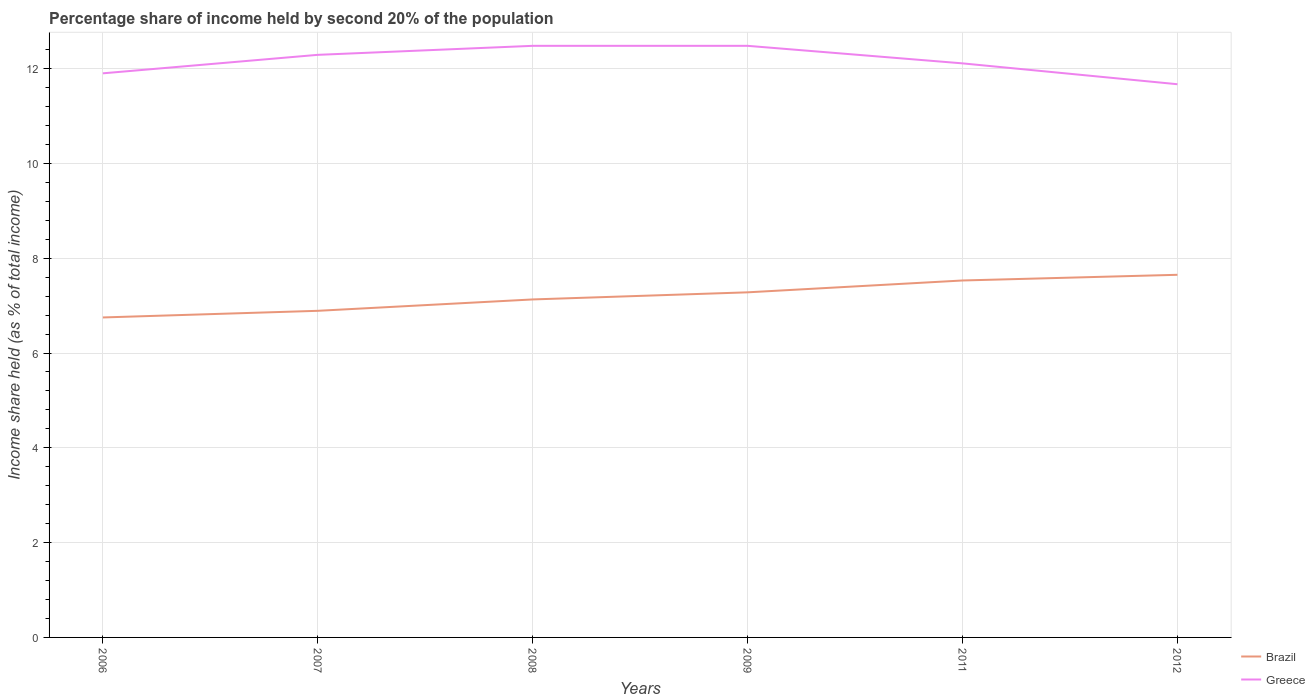Is the number of lines equal to the number of legend labels?
Provide a succinct answer. Yes. Across all years, what is the maximum share of income held by second 20% of the population in Brazil?
Make the answer very short. 6.75. What is the total share of income held by second 20% of the population in Greece in the graph?
Offer a terse response. 0.37. What is the difference between the highest and the second highest share of income held by second 20% of the population in Greece?
Offer a very short reply. 0.81. What is the difference between the highest and the lowest share of income held by second 20% of the population in Brazil?
Offer a very short reply. 3. How many lines are there?
Make the answer very short. 2. What is the difference between two consecutive major ticks on the Y-axis?
Offer a terse response. 2. Are the values on the major ticks of Y-axis written in scientific E-notation?
Make the answer very short. No. Does the graph contain any zero values?
Keep it short and to the point. No. Where does the legend appear in the graph?
Your answer should be very brief. Bottom right. What is the title of the graph?
Keep it short and to the point. Percentage share of income held by second 20% of the population. What is the label or title of the Y-axis?
Your answer should be very brief. Income share held (as % of total income). What is the Income share held (as % of total income) in Brazil in 2006?
Your response must be concise. 6.75. What is the Income share held (as % of total income) in Greece in 2006?
Give a very brief answer. 11.9. What is the Income share held (as % of total income) in Brazil in 2007?
Your answer should be very brief. 6.89. What is the Income share held (as % of total income) in Greece in 2007?
Provide a succinct answer. 12.29. What is the Income share held (as % of total income) in Brazil in 2008?
Offer a very short reply. 7.13. What is the Income share held (as % of total income) in Greece in 2008?
Keep it short and to the point. 12.48. What is the Income share held (as % of total income) in Brazil in 2009?
Provide a succinct answer. 7.28. What is the Income share held (as % of total income) in Greece in 2009?
Your answer should be compact. 12.48. What is the Income share held (as % of total income) of Brazil in 2011?
Ensure brevity in your answer.  7.53. What is the Income share held (as % of total income) in Greece in 2011?
Offer a terse response. 12.11. What is the Income share held (as % of total income) in Brazil in 2012?
Your answer should be very brief. 7.65. What is the Income share held (as % of total income) in Greece in 2012?
Offer a terse response. 11.67. Across all years, what is the maximum Income share held (as % of total income) in Brazil?
Ensure brevity in your answer.  7.65. Across all years, what is the maximum Income share held (as % of total income) in Greece?
Offer a very short reply. 12.48. Across all years, what is the minimum Income share held (as % of total income) of Brazil?
Offer a very short reply. 6.75. Across all years, what is the minimum Income share held (as % of total income) in Greece?
Ensure brevity in your answer.  11.67. What is the total Income share held (as % of total income) of Brazil in the graph?
Ensure brevity in your answer.  43.23. What is the total Income share held (as % of total income) of Greece in the graph?
Ensure brevity in your answer.  72.93. What is the difference between the Income share held (as % of total income) of Brazil in 2006 and that in 2007?
Offer a very short reply. -0.14. What is the difference between the Income share held (as % of total income) of Greece in 2006 and that in 2007?
Provide a succinct answer. -0.39. What is the difference between the Income share held (as % of total income) of Brazil in 2006 and that in 2008?
Ensure brevity in your answer.  -0.38. What is the difference between the Income share held (as % of total income) in Greece in 2006 and that in 2008?
Ensure brevity in your answer.  -0.58. What is the difference between the Income share held (as % of total income) in Brazil in 2006 and that in 2009?
Your answer should be compact. -0.53. What is the difference between the Income share held (as % of total income) of Greece in 2006 and that in 2009?
Your answer should be compact. -0.58. What is the difference between the Income share held (as % of total income) of Brazil in 2006 and that in 2011?
Provide a succinct answer. -0.78. What is the difference between the Income share held (as % of total income) in Greece in 2006 and that in 2011?
Your answer should be compact. -0.21. What is the difference between the Income share held (as % of total income) in Brazil in 2006 and that in 2012?
Provide a short and direct response. -0.9. What is the difference between the Income share held (as % of total income) in Greece in 2006 and that in 2012?
Keep it short and to the point. 0.23. What is the difference between the Income share held (as % of total income) of Brazil in 2007 and that in 2008?
Make the answer very short. -0.24. What is the difference between the Income share held (as % of total income) of Greece in 2007 and that in 2008?
Your answer should be compact. -0.19. What is the difference between the Income share held (as % of total income) of Brazil in 2007 and that in 2009?
Make the answer very short. -0.39. What is the difference between the Income share held (as % of total income) of Greece in 2007 and that in 2009?
Offer a very short reply. -0.19. What is the difference between the Income share held (as % of total income) of Brazil in 2007 and that in 2011?
Offer a very short reply. -0.64. What is the difference between the Income share held (as % of total income) of Greece in 2007 and that in 2011?
Your answer should be compact. 0.18. What is the difference between the Income share held (as % of total income) of Brazil in 2007 and that in 2012?
Give a very brief answer. -0.76. What is the difference between the Income share held (as % of total income) in Greece in 2007 and that in 2012?
Your answer should be very brief. 0.62. What is the difference between the Income share held (as % of total income) of Brazil in 2008 and that in 2009?
Your answer should be compact. -0.15. What is the difference between the Income share held (as % of total income) in Brazil in 2008 and that in 2011?
Offer a terse response. -0.4. What is the difference between the Income share held (as % of total income) in Greece in 2008 and that in 2011?
Your response must be concise. 0.37. What is the difference between the Income share held (as % of total income) of Brazil in 2008 and that in 2012?
Ensure brevity in your answer.  -0.52. What is the difference between the Income share held (as % of total income) in Greece in 2008 and that in 2012?
Give a very brief answer. 0.81. What is the difference between the Income share held (as % of total income) of Greece in 2009 and that in 2011?
Provide a short and direct response. 0.37. What is the difference between the Income share held (as % of total income) of Brazil in 2009 and that in 2012?
Ensure brevity in your answer.  -0.37. What is the difference between the Income share held (as % of total income) in Greece in 2009 and that in 2012?
Ensure brevity in your answer.  0.81. What is the difference between the Income share held (as % of total income) in Brazil in 2011 and that in 2012?
Give a very brief answer. -0.12. What is the difference between the Income share held (as % of total income) of Greece in 2011 and that in 2012?
Your response must be concise. 0.44. What is the difference between the Income share held (as % of total income) of Brazil in 2006 and the Income share held (as % of total income) of Greece in 2007?
Your response must be concise. -5.54. What is the difference between the Income share held (as % of total income) in Brazil in 2006 and the Income share held (as % of total income) in Greece in 2008?
Provide a succinct answer. -5.73. What is the difference between the Income share held (as % of total income) in Brazil in 2006 and the Income share held (as % of total income) in Greece in 2009?
Ensure brevity in your answer.  -5.73. What is the difference between the Income share held (as % of total income) in Brazil in 2006 and the Income share held (as % of total income) in Greece in 2011?
Make the answer very short. -5.36. What is the difference between the Income share held (as % of total income) of Brazil in 2006 and the Income share held (as % of total income) of Greece in 2012?
Provide a succinct answer. -4.92. What is the difference between the Income share held (as % of total income) in Brazil in 2007 and the Income share held (as % of total income) in Greece in 2008?
Provide a short and direct response. -5.59. What is the difference between the Income share held (as % of total income) of Brazil in 2007 and the Income share held (as % of total income) of Greece in 2009?
Your answer should be very brief. -5.59. What is the difference between the Income share held (as % of total income) of Brazil in 2007 and the Income share held (as % of total income) of Greece in 2011?
Your answer should be compact. -5.22. What is the difference between the Income share held (as % of total income) of Brazil in 2007 and the Income share held (as % of total income) of Greece in 2012?
Your answer should be very brief. -4.78. What is the difference between the Income share held (as % of total income) in Brazil in 2008 and the Income share held (as % of total income) in Greece in 2009?
Give a very brief answer. -5.35. What is the difference between the Income share held (as % of total income) in Brazil in 2008 and the Income share held (as % of total income) in Greece in 2011?
Offer a very short reply. -4.98. What is the difference between the Income share held (as % of total income) of Brazil in 2008 and the Income share held (as % of total income) of Greece in 2012?
Your answer should be very brief. -4.54. What is the difference between the Income share held (as % of total income) of Brazil in 2009 and the Income share held (as % of total income) of Greece in 2011?
Your answer should be very brief. -4.83. What is the difference between the Income share held (as % of total income) of Brazil in 2009 and the Income share held (as % of total income) of Greece in 2012?
Offer a terse response. -4.39. What is the difference between the Income share held (as % of total income) in Brazil in 2011 and the Income share held (as % of total income) in Greece in 2012?
Ensure brevity in your answer.  -4.14. What is the average Income share held (as % of total income) of Brazil per year?
Make the answer very short. 7.21. What is the average Income share held (as % of total income) in Greece per year?
Provide a short and direct response. 12.15. In the year 2006, what is the difference between the Income share held (as % of total income) in Brazil and Income share held (as % of total income) in Greece?
Ensure brevity in your answer.  -5.15. In the year 2008, what is the difference between the Income share held (as % of total income) of Brazil and Income share held (as % of total income) of Greece?
Your answer should be very brief. -5.35. In the year 2011, what is the difference between the Income share held (as % of total income) of Brazil and Income share held (as % of total income) of Greece?
Offer a very short reply. -4.58. In the year 2012, what is the difference between the Income share held (as % of total income) in Brazil and Income share held (as % of total income) in Greece?
Your response must be concise. -4.02. What is the ratio of the Income share held (as % of total income) of Brazil in 2006 to that in 2007?
Your answer should be very brief. 0.98. What is the ratio of the Income share held (as % of total income) of Greece in 2006 to that in 2007?
Offer a very short reply. 0.97. What is the ratio of the Income share held (as % of total income) in Brazil in 2006 to that in 2008?
Provide a succinct answer. 0.95. What is the ratio of the Income share held (as % of total income) of Greece in 2006 to that in 2008?
Offer a terse response. 0.95. What is the ratio of the Income share held (as % of total income) in Brazil in 2006 to that in 2009?
Ensure brevity in your answer.  0.93. What is the ratio of the Income share held (as % of total income) of Greece in 2006 to that in 2009?
Make the answer very short. 0.95. What is the ratio of the Income share held (as % of total income) in Brazil in 2006 to that in 2011?
Provide a succinct answer. 0.9. What is the ratio of the Income share held (as % of total income) of Greece in 2006 to that in 2011?
Your response must be concise. 0.98. What is the ratio of the Income share held (as % of total income) in Brazil in 2006 to that in 2012?
Your answer should be very brief. 0.88. What is the ratio of the Income share held (as % of total income) in Greece in 2006 to that in 2012?
Give a very brief answer. 1.02. What is the ratio of the Income share held (as % of total income) of Brazil in 2007 to that in 2008?
Provide a short and direct response. 0.97. What is the ratio of the Income share held (as % of total income) of Brazil in 2007 to that in 2009?
Provide a short and direct response. 0.95. What is the ratio of the Income share held (as % of total income) in Brazil in 2007 to that in 2011?
Ensure brevity in your answer.  0.92. What is the ratio of the Income share held (as % of total income) of Greece in 2007 to that in 2011?
Offer a very short reply. 1.01. What is the ratio of the Income share held (as % of total income) in Brazil in 2007 to that in 2012?
Your response must be concise. 0.9. What is the ratio of the Income share held (as % of total income) in Greece in 2007 to that in 2012?
Provide a short and direct response. 1.05. What is the ratio of the Income share held (as % of total income) of Brazil in 2008 to that in 2009?
Make the answer very short. 0.98. What is the ratio of the Income share held (as % of total income) in Brazil in 2008 to that in 2011?
Keep it short and to the point. 0.95. What is the ratio of the Income share held (as % of total income) in Greece in 2008 to that in 2011?
Your response must be concise. 1.03. What is the ratio of the Income share held (as % of total income) in Brazil in 2008 to that in 2012?
Provide a short and direct response. 0.93. What is the ratio of the Income share held (as % of total income) of Greece in 2008 to that in 2012?
Keep it short and to the point. 1.07. What is the ratio of the Income share held (as % of total income) in Brazil in 2009 to that in 2011?
Keep it short and to the point. 0.97. What is the ratio of the Income share held (as % of total income) of Greece in 2009 to that in 2011?
Make the answer very short. 1.03. What is the ratio of the Income share held (as % of total income) of Brazil in 2009 to that in 2012?
Provide a short and direct response. 0.95. What is the ratio of the Income share held (as % of total income) in Greece in 2009 to that in 2012?
Provide a succinct answer. 1.07. What is the ratio of the Income share held (as % of total income) in Brazil in 2011 to that in 2012?
Make the answer very short. 0.98. What is the ratio of the Income share held (as % of total income) in Greece in 2011 to that in 2012?
Offer a very short reply. 1.04. What is the difference between the highest and the second highest Income share held (as % of total income) of Brazil?
Make the answer very short. 0.12. What is the difference between the highest and the second highest Income share held (as % of total income) of Greece?
Offer a terse response. 0. What is the difference between the highest and the lowest Income share held (as % of total income) in Brazil?
Offer a terse response. 0.9. What is the difference between the highest and the lowest Income share held (as % of total income) of Greece?
Make the answer very short. 0.81. 